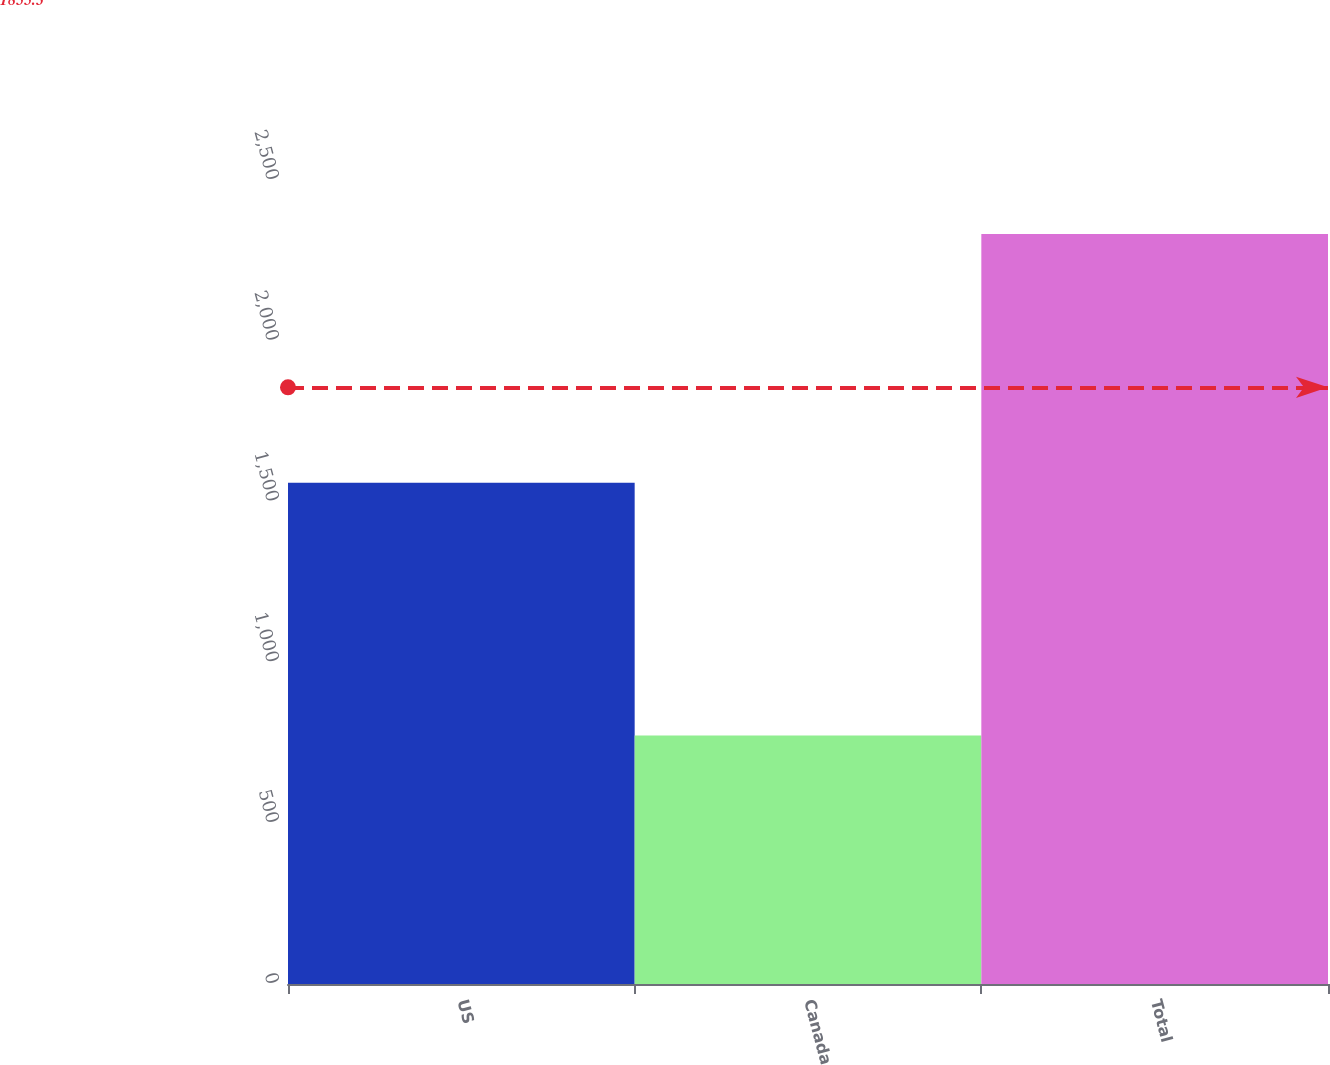Convert chart. <chart><loc_0><loc_0><loc_500><loc_500><bar_chart><fcel>US<fcel>Canada<fcel>Total<nl><fcel>1559<fcel>773<fcel>2332<nl></chart> 